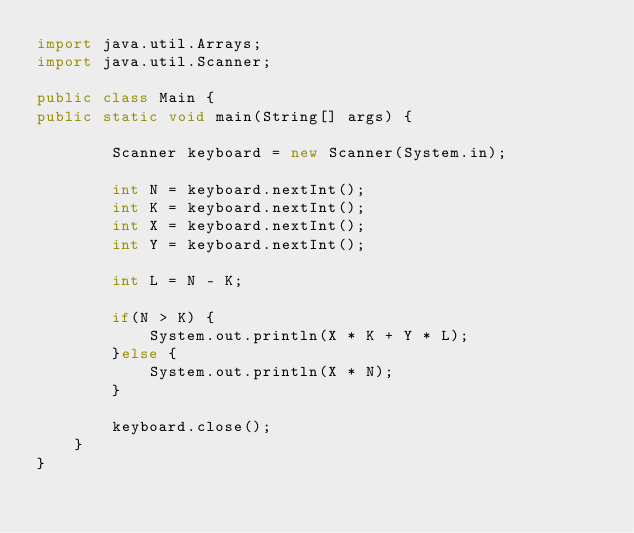<code> <loc_0><loc_0><loc_500><loc_500><_Java_>import java.util.Arrays;
import java.util.Scanner;

public class Main {
public static void main(String[] args) {
		
		Scanner keyboard = new Scanner(System.in); 
		
		int N = keyboard.nextInt();
		int K = keyboard.nextInt();
		int X = keyboard.nextInt();
		int Y = keyboard.nextInt();
		
		int L = N - K;
		
		if(N > K) {
			System.out.println(X * K + Y * L);
		}else {
			System.out.println(X * N);
		}
			
		keyboard.close();	
	}
}
</code> 